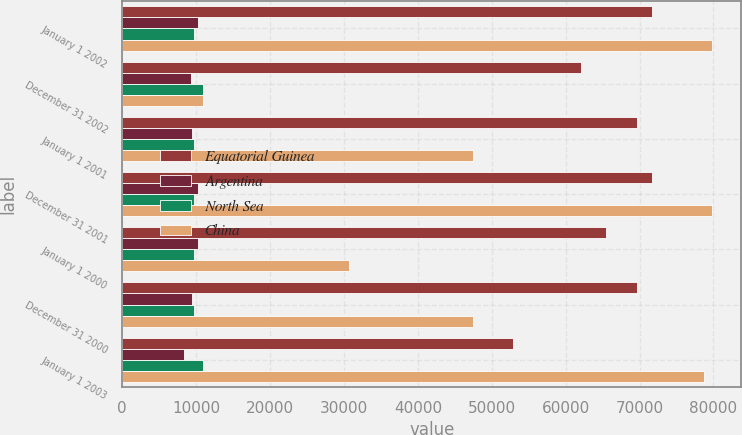<chart> <loc_0><loc_0><loc_500><loc_500><stacked_bar_chart><ecel><fcel>January 1 2002<fcel>December 31 2002<fcel>January 1 2001<fcel>December 31 2001<fcel>January 1 2000<fcel>December 31 2000<fcel>January 1 2003<nl><fcel>Equatorial Guinea<fcel>71672<fcel>62023<fcel>69700<fcel>71672<fcel>65523<fcel>69700<fcel>52847<nl><fcel>Argentina<fcel>10277<fcel>9283<fcel>9437<fcel>10277<fcel>10285<fcel>9437<fcel>8331<nl><fcel>North Sea<fcel>9768<fcel>10930<fcel>9768<fcel>9768<fcel>9768<fcel>9768<fcel>10930<nl><fcel>China<fcel>79790<fcel>10930<fcel>47446<fcel>79790<fcel>30684<fcel>47446<fcel>78746<nl></chart> 